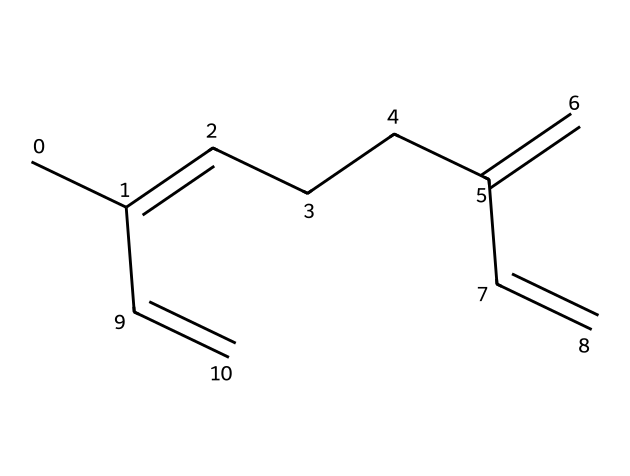What is the molecular formula of myrcene? The molecular formula can be derived from the number of carbon and hydrogen atoms present in the SMILES representation. In this case, there are 10 carbon atoms and 16 hydrogen atoms, resulting in the formula C10H16.
Answer: C10H16 How many double bonds are present in myrcene? By analyzing the SMILES representation, we can see that there are three double bonds indicated by the '=' signs. These contribute to myrcene's unsaturated nature.
Answer: 3 What type of organic compound is myrcene classified as? Myrcene falls under the category of terpenes due to its hydrocarbon structure and its occurrence in essential oils, such as that of lemongrass.
Answer: terpene Is myrcene a cyclic or acyclic compound? The structure of myrcene shows a linear arrangement of carbon atoms without any rings, indicating it is an acyclic compound.
Answer: acyclic What is the significance of myrcene in recovery teas? Myrcene is known for its calming and anti-inflammatory properties, which may aid in muscle recovery after training, making it significant in recovery teas.
Answer: calming properties How many stereocenters are present in the myrcene structure? Upon examining the structure, it appears there are no stereocenters as no carbon atoms are bonded to four different substituents.
Answer: 0 